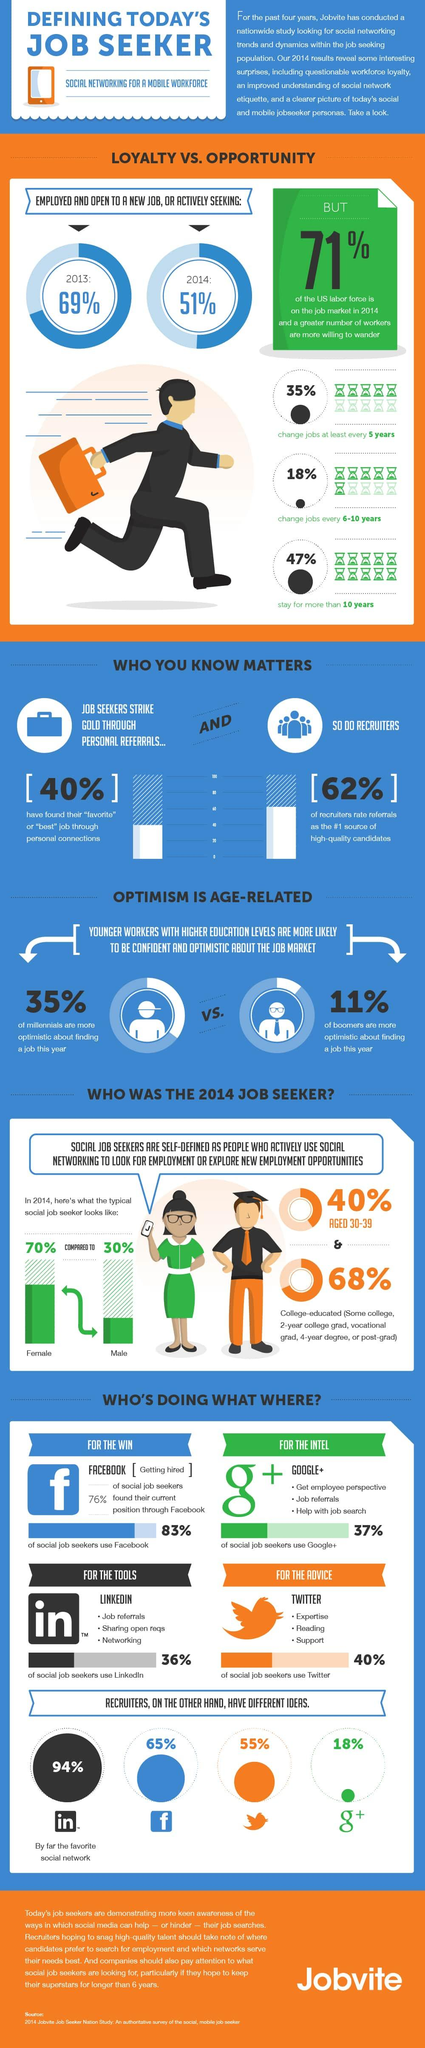Draw attention to some important aspects in this diagram. The color of the woman's dress is green. The number of women seeking social jobs is higher than that of men. The color of the bird Twitter icon is orange. In 2013, more people were employed and open to new job opportunities. According to a survey of recruiters, 38% do not believe that referrals are the top source of high-quality candidates. 